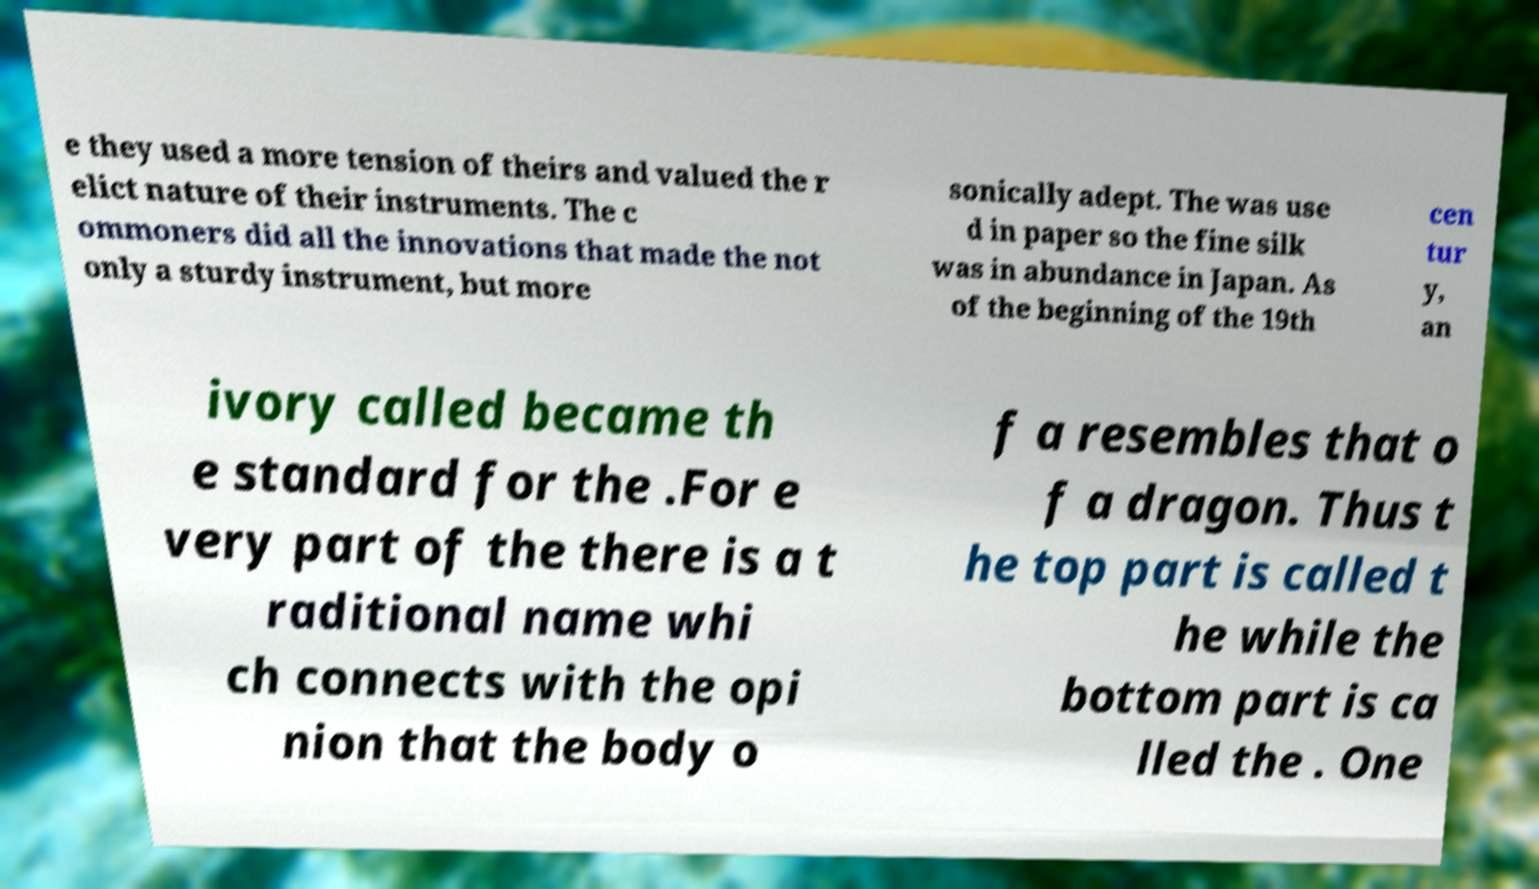Please identify and transcribe the text found in this image. e they used a more tension of theirs and valued the r elict nature of their instruments. The c ommoners did all the innovations that made the not only a sturdy instrument, but more sonically adept. The was use d in paper so the fine silk was in abundance in Japan. As of the beginning of the 19th cen tur y, an ivory called became th e standard for the .For e very part of the there is a t raditional name whi ch connects with the opi nion that the body o f a resembles that o f a dragon. Thus t he top part is called t he while the bottom part is ca lled the . One 